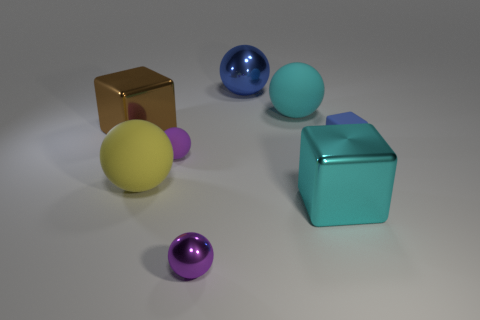Subtract 1 balls. How many balls are left? 4 Subtract all blue balls. How many balls are left? 4 Subtract all large shiny balls. How many balls are left? 4 Add 1 tiny rubber blocks. How many objects exist? 9 Subtract all red balls. Subtract all yellow cylinders. How many balls are left? 5 Subtract all spheres. How many objects are left? 3 Add 1 tiny cyan cylinders. How many tiny cyan cylinders exist? 1 Subtract 1 cyan spheres. How many objects are left? 7 Subtract all large blue things. Subtract all small purple objects. How many objects are left? 5 Add 4 purple rubber things. How many purple rubber things are left? 5 